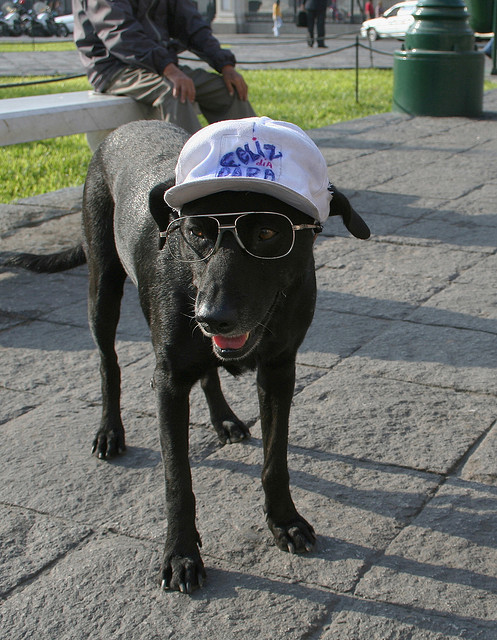Please transcribe the text information in this image. BAPA 